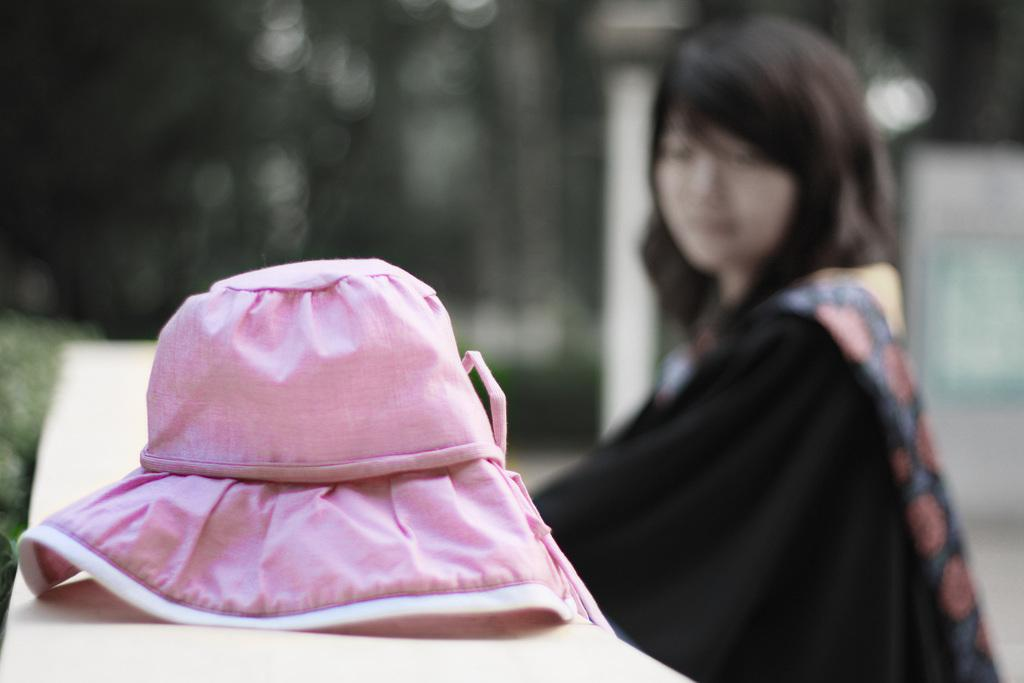What object is present in the image? There is a cap in the image. What is the color of the cap? The cap is pink in color. Can you describe the background of the image? There is a person sitting and trees in the background of the image. What is the color of the trees? The trees are green in color. What type of wood is used to make the cake in the image? There is no cake present in the image, so it is not possible to determine the type of wood used to make it. 